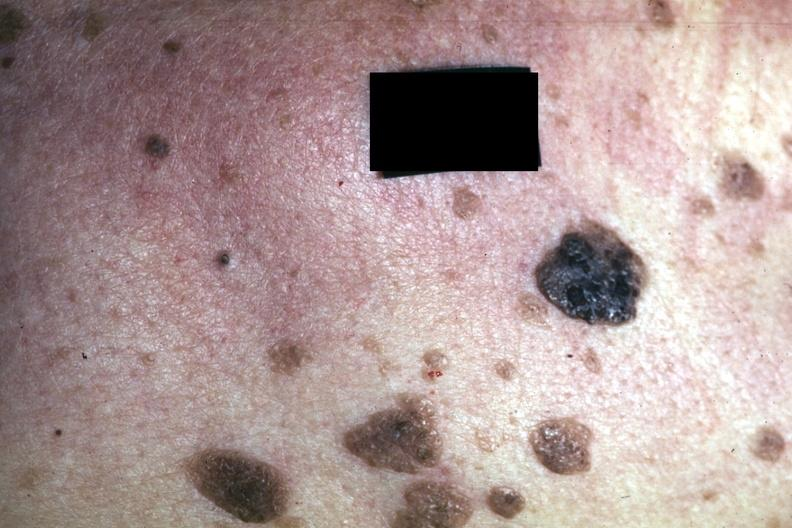what is present?
Answer the question using a single word or phrase. Seborrheic keratosis 